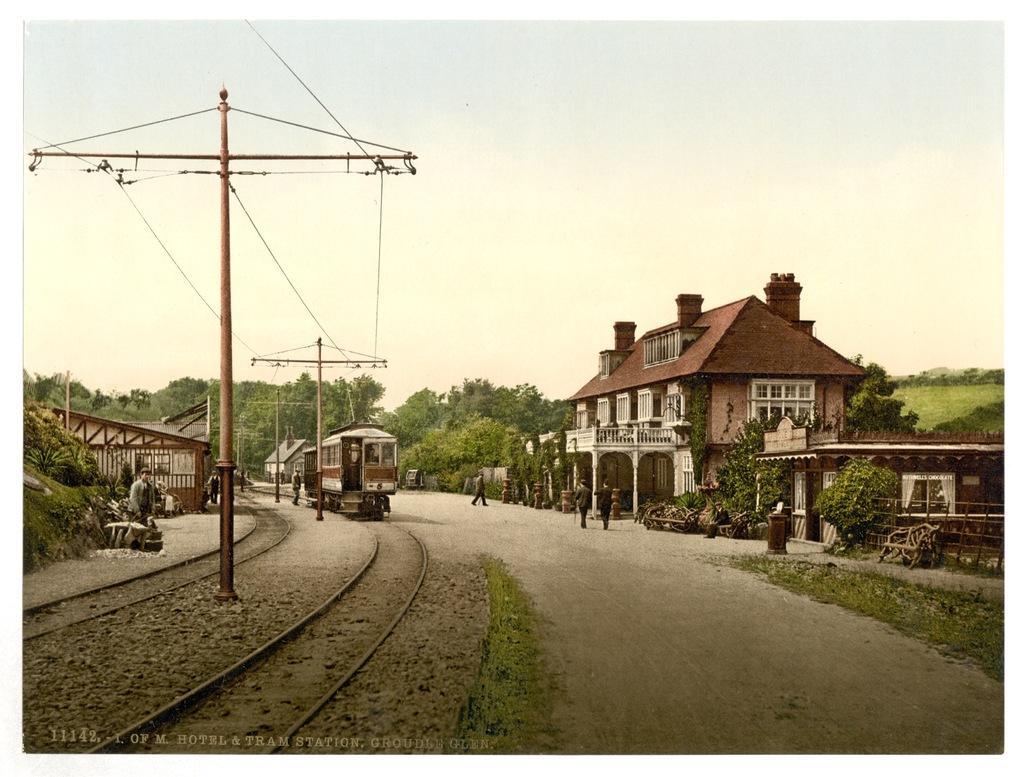Could you give a brief overview of what you see in this image? On the left side, I can see the railway tracks and poles along with the wires. In the background there is a train. On the right side there is a road. In the background I can see the buildings and trees. At the top of the image I can see the sky. Here I can see few people are walking on the road. 